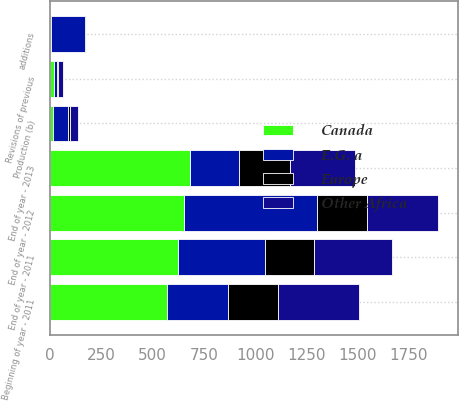Convert chart to OTSL. <chart><loc_0><loc_0><loc_500><loc_500><stacked_bar_chart><ecel><fcel>Beginning of year - 2011<fcel>Revisions of previous<fcel>End of year - 2011<fcel>End of year - 2012<fcel>additions<fcel>Production (b)<fcel>End of year - 2013<nl><fcel>E.G. a<fcel>297<fcel>19<fcel>424<fcel>649<fcel>164<fcel>74<fcel>242<nl><fcel>Canada<fcel>572<fcel>17<fcel>623<fcel>653<fcel>6<fcel>15<fcel>680<nl><fcel>Other Africa<fcel>394<fcel>25<fcel>379<fcel>347<fcel>2<fcel>39<fcel>318<nl><fcel>Europe<fcel>242<fcel>1<fcel>239<fcel>244<fcel>3<fcel>10<fcel>249<nl></chart> 